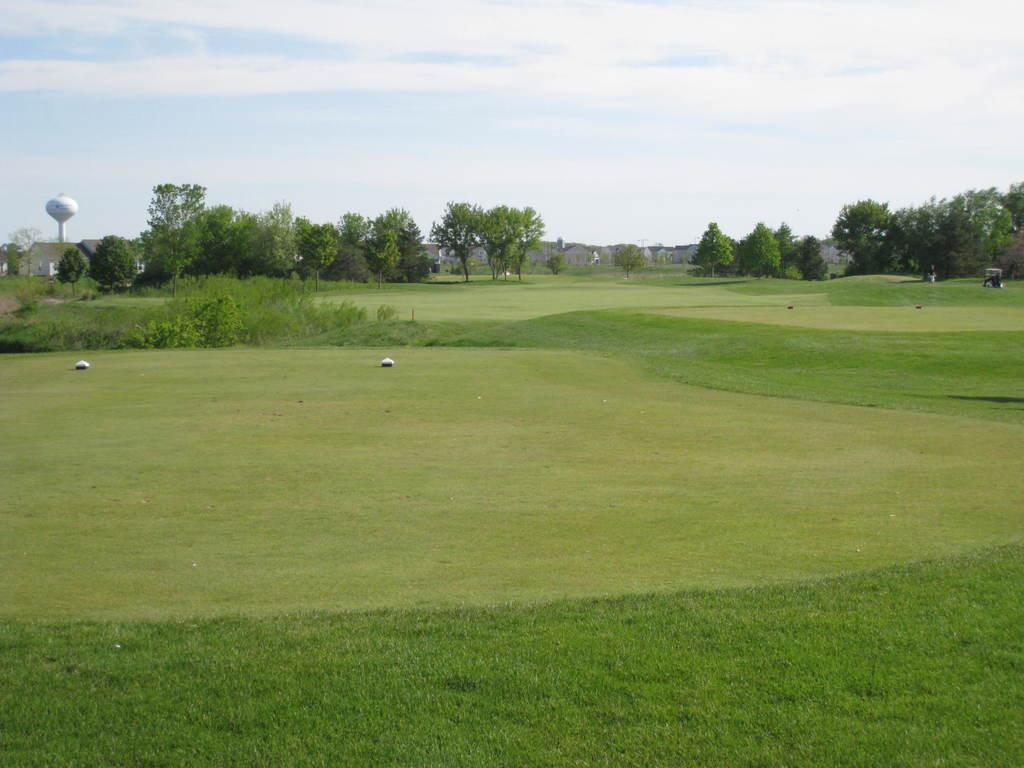What can be seen at the bottom of the image? The ground is visible in the image. What type of natural environment is depicted in the background? There are many trees and clouds visible in the background of the image. What is located on the left side of the image? There is a white color pole on the left side of the image. What is visible in the sky in the background of the image? The sky is visible in the background of the image. What type of wave can be seen crashing on the shore in the image? There is no wave or shore present in the image; it features a pole, trees, and a sky. How does the care for the trees in the image appear to be managed? There is no indication of tree care management in the image; it simply shows trees in the background. 